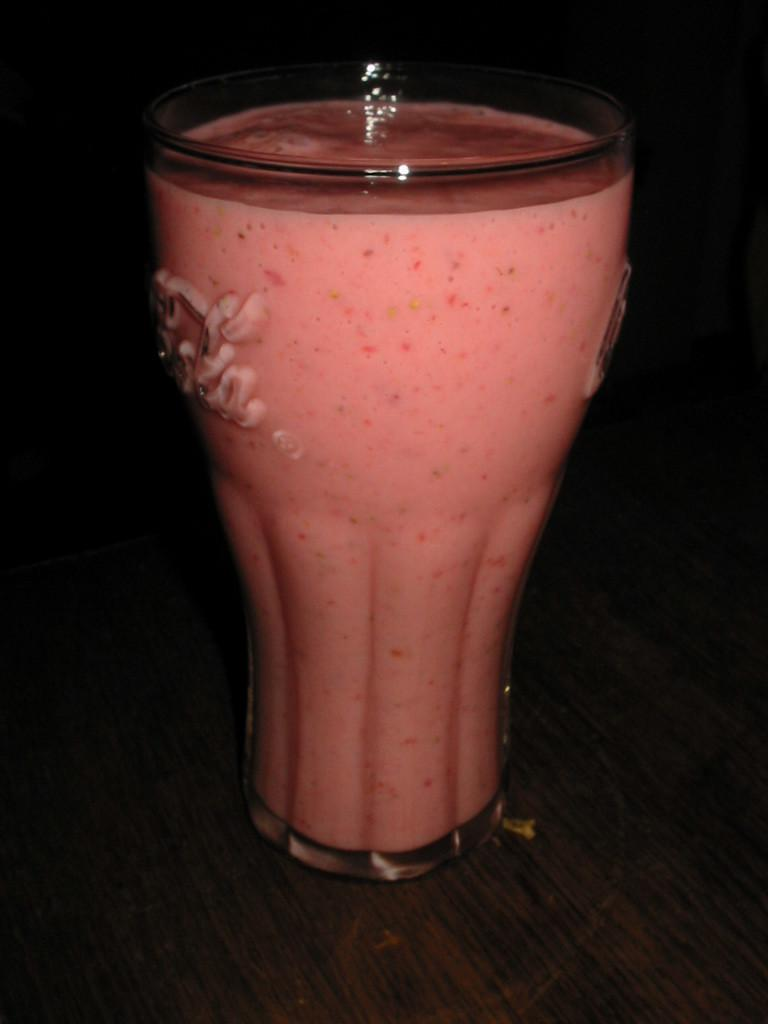What is present in the image that can hold a liquid? There is a glass in the image that can hold a liquid. What is inside the glass? The glass is filled with a liquid substance. On what surface is the glass placed? The glass is placed on a wooden surface. How many dinosaurs can be seen in the image? There are no dinosaurs present in the image. Is there a person in the image? There is no person present in the image. 